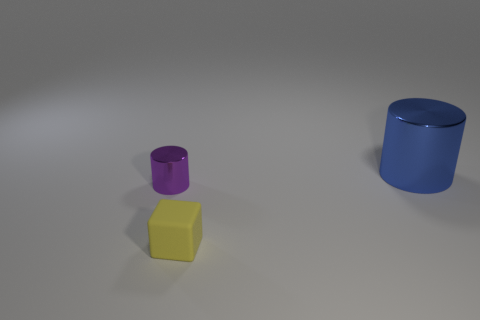Is there any other thing that is the same size as the blue shiny cylinder?
Keep it short and to the point. No. There is a shiny thing that is to the left of the large metal object; is its color the same as the small rubber cube?
Provide a short and direct response. No. How many balls are either brown rubber things or big things?
Offer a very short reply. 0. What is the size of the cylinder to the left of the tiny cube that is in front of the object right of the tiny block?
Offer a very short reply. Small. There is another object that is the same size as the yellow thing; what shape is it?
Your response must be concise. Cylinder. The large blue thing is what shape?
Your answer should be very brief. Cylinder. Does the thing that is to the right of the yellow rubber thing have the same material as the purple cylinder?
Keep it short and to the point. Yes. How big is the shiny cylinder that is on the right side of the metal cylinder that is in front of the blue cylinder?
Give a very brief answer. Large. There is a thing that is both on the right side of the tiny cylinder and in front of the big blue thing; what is its color?
Make the answer very short. Yellow. What material is the yellow block that is the same size as the purple metal thing?
Ensure brevity in your answer.  Rubber. 